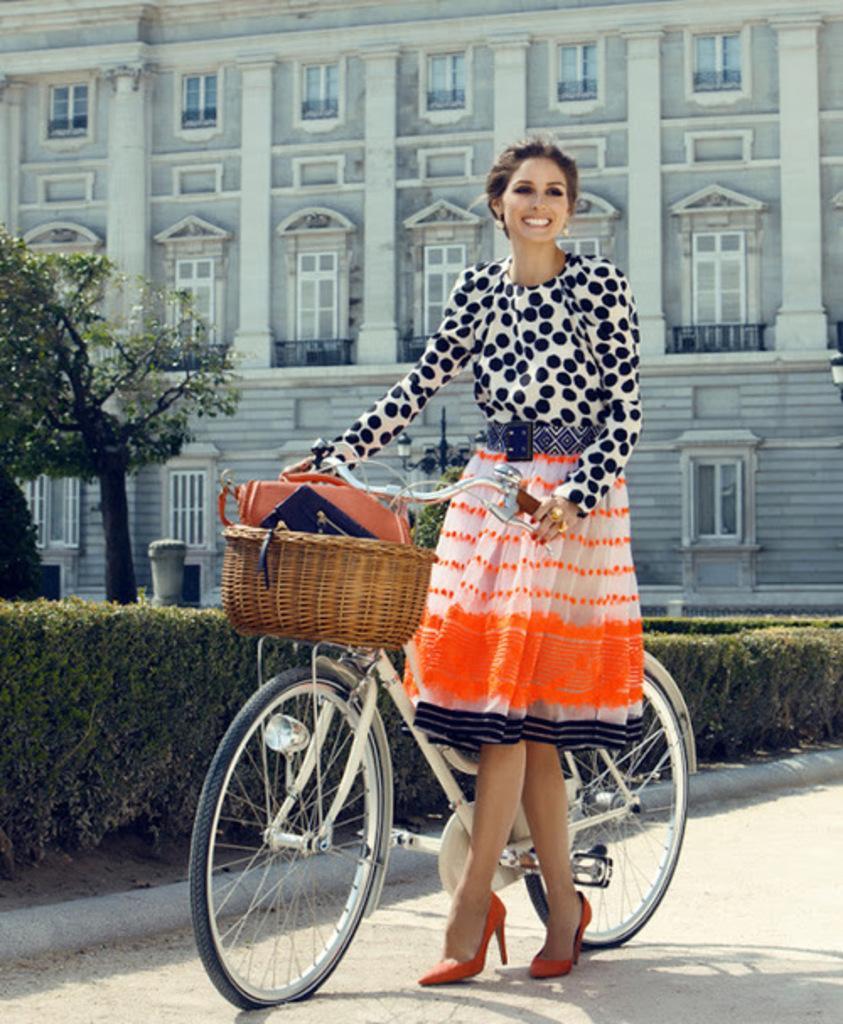In one or two sentences, can you explain what this image depicts? In this image we can see a woman standing on the ground holding a bicycle. We can also see some plants, trees and a building with windows and pillars. 